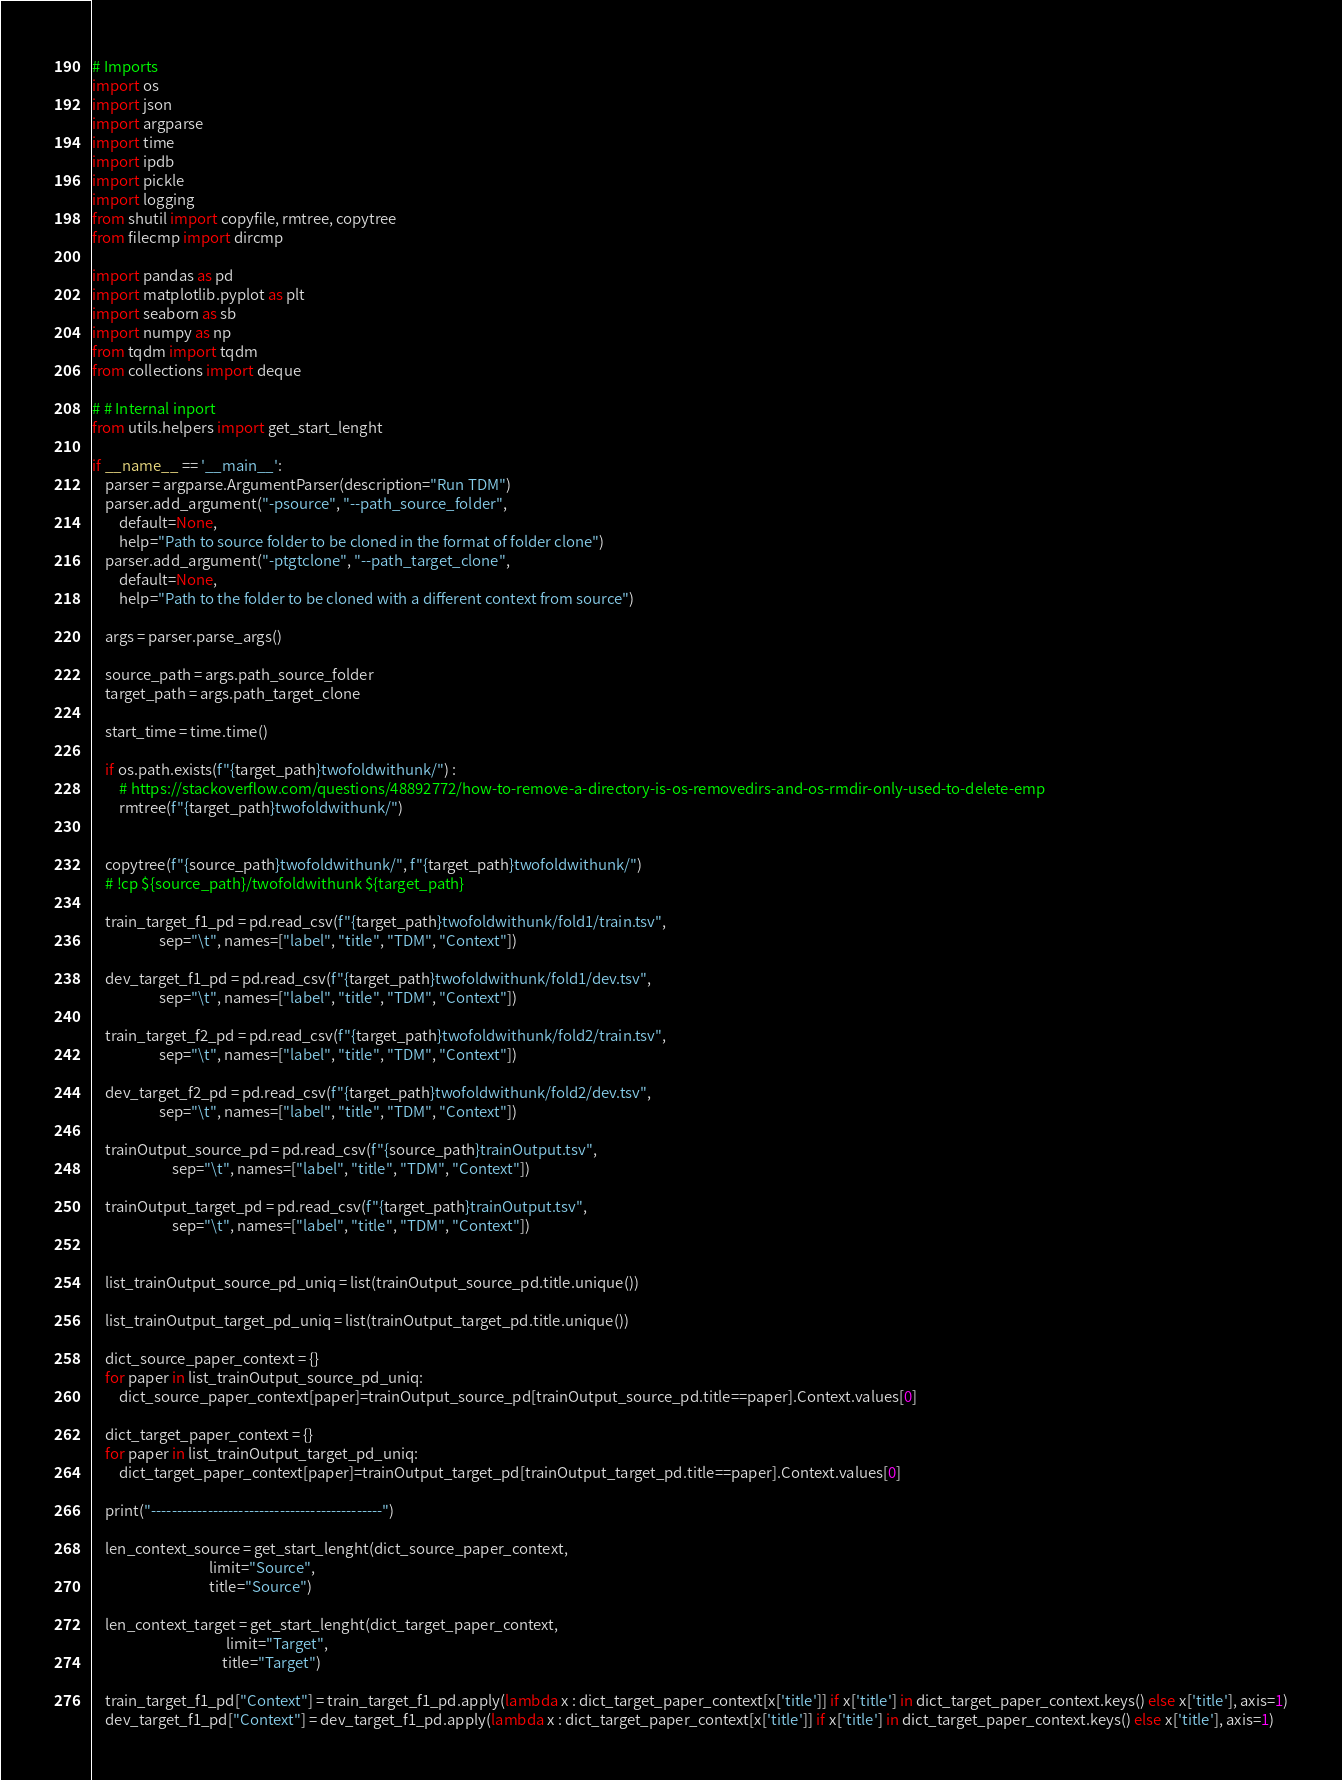Convert code to text. <code><loc_0><loc_0><loc_500><loc_500><_Python_># Imports 
import os
import json
import argparse
import time
import ipdb
import pickle
import logging
from shutil import copyfile, rmtree, copytree
from filecmp import dircmp

import pandas as pd
import matplotlib.pyplot as plt
import seaborn as sb
import numpy as np
from tqdm import tqdm
from collections import deque

# # Internal inport 
from utils.helpers import get_start_lenght

if __name__ == '__main__':
    parser = argparse.ArgumentParser(description="Run TDM")
    parser.add_argument("-psource", "--path_source_folder", 
        default=None, 
        help="Path to source folder to be cloned in the format of folder clone")
    parser.add_argument("-ptgtclone", "--path_target_clone", 
        default=None, 
        help="Path to the folder to be cloned with a different context from source")
    
    args = parser.parse_args()

    source_path = args.path_source_folder
    target_path = args.path_target_clone

    start_time = time.time()

    if os.path.exists(f"{target_path}twofoldwithunk/") :
        # https://stackoverflow.com/questions/48892772/how-to-remove-a-directory-is-os-removedirs-and-os-rmdir-only-used-to-delete-emp
        rmtree(f"{target_path}twofoldwithunk/")
    
    
    copytree(f"{source_path}twofoldwithunk/", f"{target_path}twofoldwithunk/")
    # !cp ${source_path}/twofoldwithunk ${target_path}

    train_target_f1_pd = pd.read_csv(f"{target_path}twofoldwithunk/fold1/train.tsv", 
                    sep="\t", names=["label", "title", "TDM", "Context"])

    dev_target_f1_pd = pd.read_csv(f"{target_path}twofoldwithunk/fold1/dev.tsv", 
                    sep="\t", names=["label", "title", "TDM", "Context"])

    train_target_f2_pd = pd.read_csv(f"{target_path}twofoldwithunk/fold2/train.tsv", 
                    sep="\t", names=["label", "title", "TDM", "Context"])

    dev_target_f2_pd = pd.read_csv(f"{target_path}twofoldwithunk/fold2/dev.tsv", 
                    sep="\t", names=["label", "title", "TDM", "Context"])

    trainOutput_source_pd = pd.read_csv(f"{source_path}trainOutput.tsv", 
                        sep="\t", names=["label", "title", "TDM", "Context"])

    trainOutput_target_pd = pd.read_csv(f"{target_path}trainOutput.tsv", 
                        sep="\t", names=["label", "title", "TDM", "Context"])


    list_trainOutput_source_pd_uniq = list(trainOutput_source_pd.title.unique())

    list_trainOutput_target_pd_uniq = list(trainOutput_target_pd.title.unique())

    dict_source_paper_context = {}
    for paper in list_trainOutput_source_pd_uniq:
        dict_source_paper_context[paper]=trainOutput_source_pd[trainOutput_source_pd.title==paper].Context.values[0]
        
    dict_target_paper_context = {}
    for paper in list_trainOutput_target_pd_uniq:
        dict_target_paper_context[paper]=trainOutput_target_pd[trainOutput_target_pd.title==paper].Context.values[0]

    print("---------------------------------------------")

    len_context_source = get_start_lenght(dict_source_paper_context, 
                                   limit="Source", 
                                   title="Source")

    len_context_target = get_start_lenght(dict_target_paper_context, 
                                        limit="Target",
                                       title="Target")

    train_target_f1_pd["Context"] = train_target_f1_pd.apply(lambda x : dict_target_paper_context[x['title']] if x['title'] in dict_target_paper_context.keys() else x['title'], axis=1)
    dev_target_f1_pd["Context"] = dev_target_f1_pd.apply(lambda x : dict_target_paper_context[x['title']] if x['title'] in dict_target_paper_context.keys() else x['title'], axis=1)
</code> 